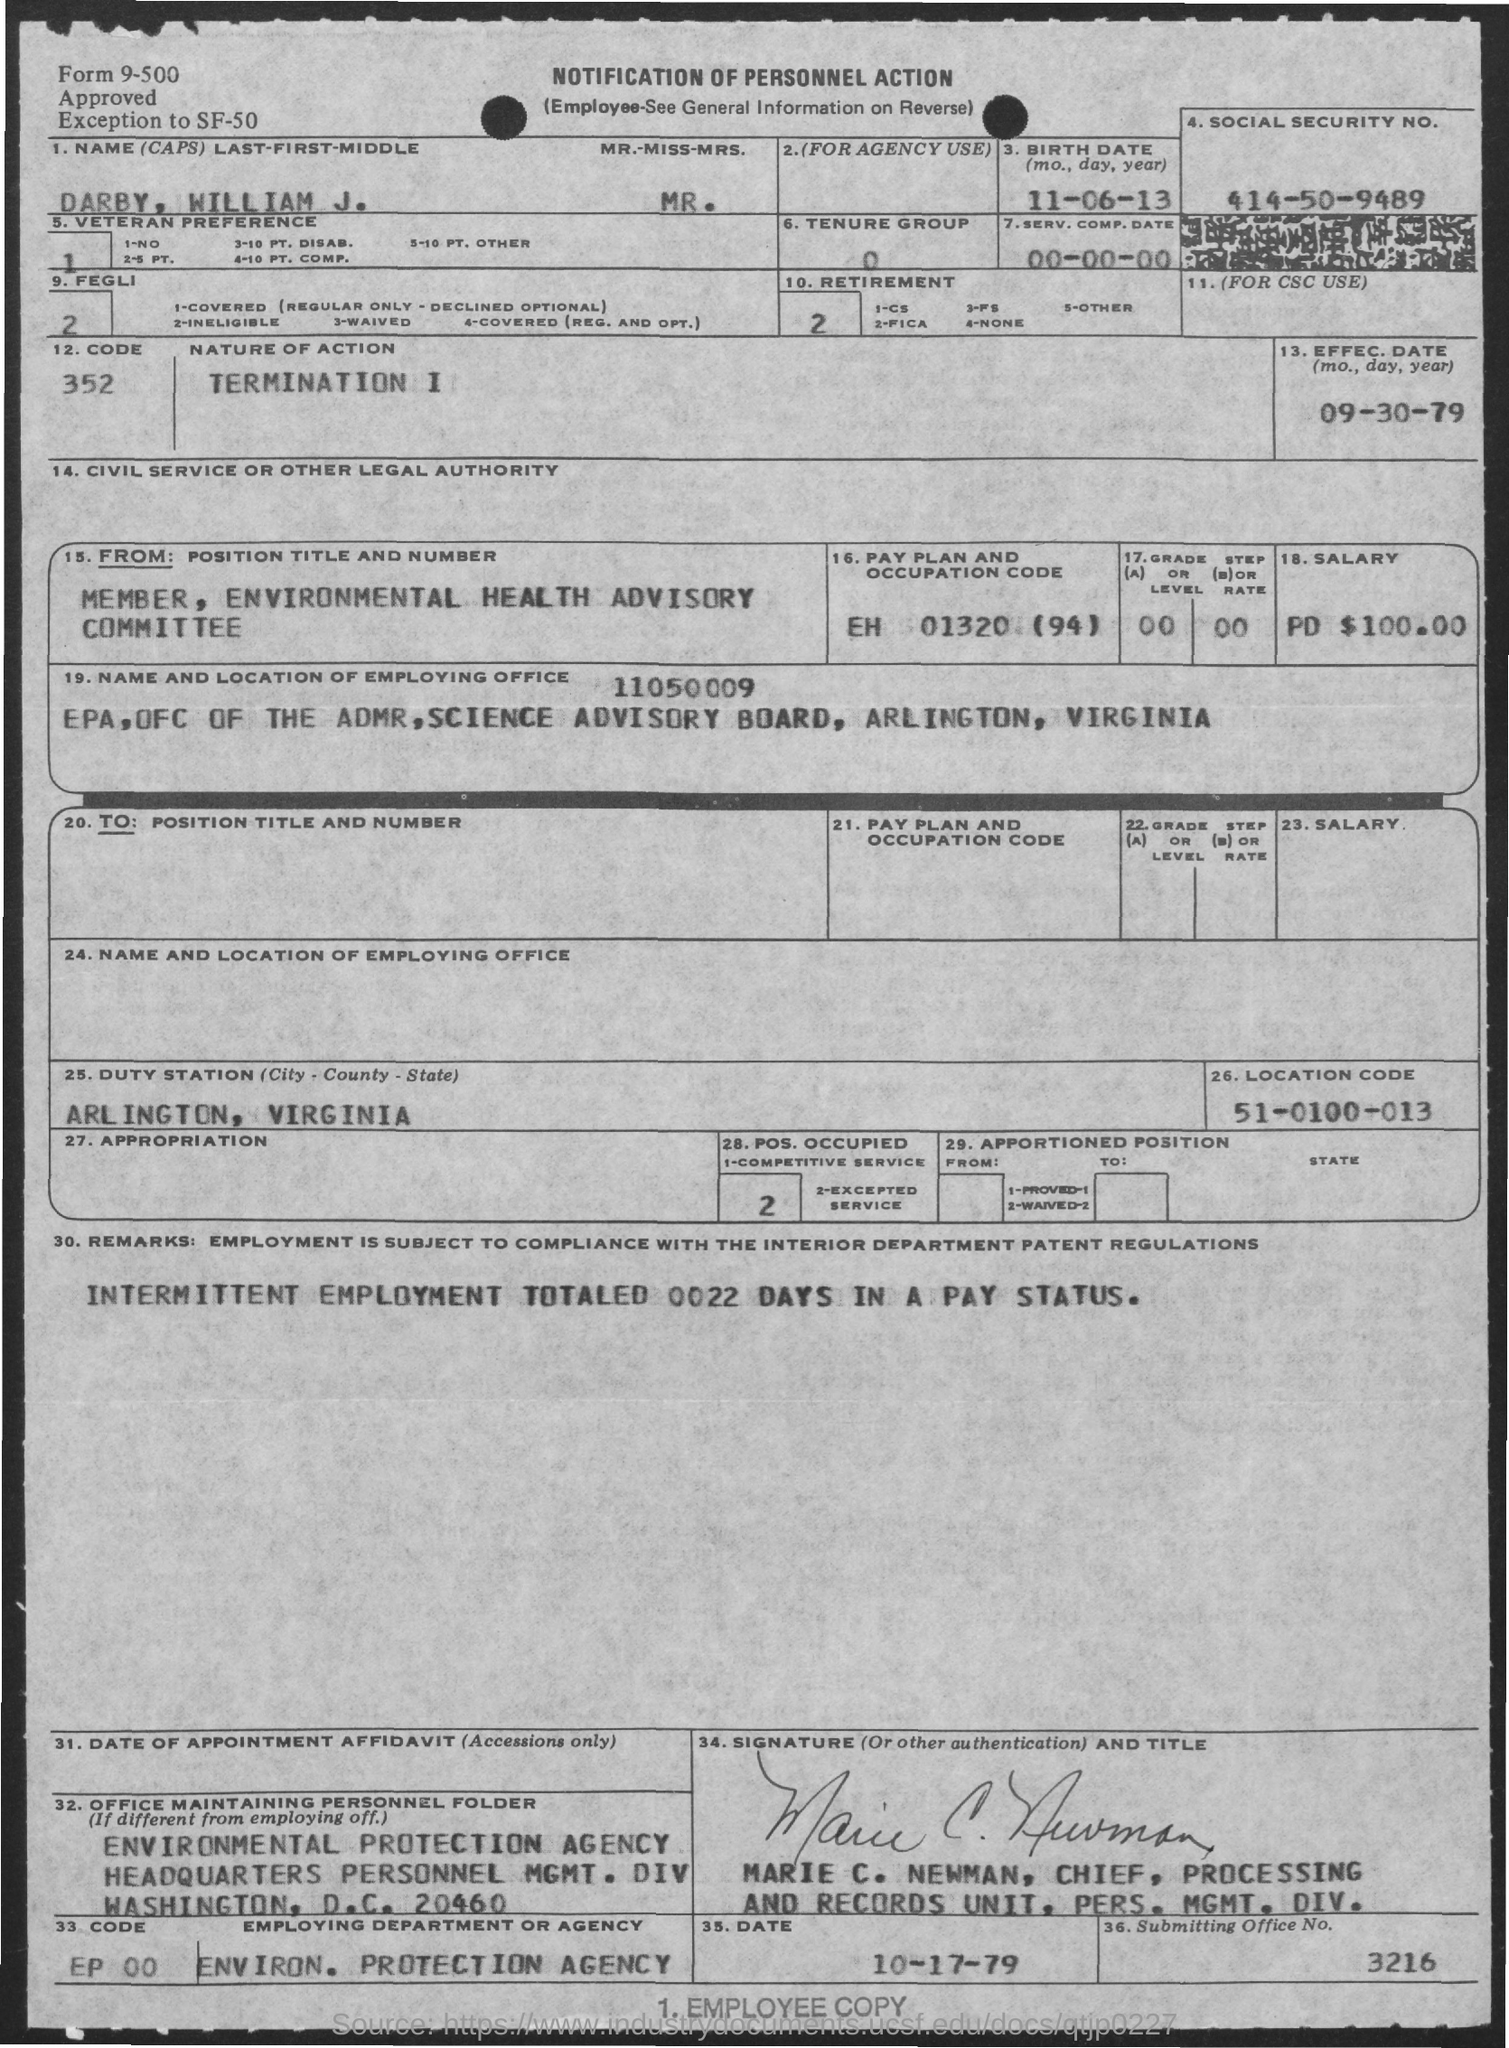Highlight a few significant elements in this photo. What is the effective date of September 30, 1979? What is the office number?" the speaker asked, with a three-digit number following the question mark. The Environmental Protection Agency (EPA) is the employing department or agency. The pay plan and occupation code of Darby William J. EH 01320 (94) are unknown. The telephone number "414-50-9489" is a social security number. 